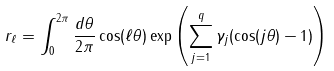<formula> <loc_0><loc_0><loc_500><loc_500>r _ { \ell } = \int _ { 0 } ^ { 2 \pi } \frac { d \theta } { 2 \pi } \cos ( \ell \theta ) \exp \left ( \sum _ { j = 1 } ^ { q } \gamma _ { j } ( \cos ( j \theta ) - 1 ) \right )</formula> 